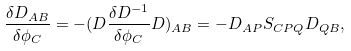Convert formula to latex. <formula><loc_0><loc_0><loc_500><loc_500>\frac { \delta D _ { A B } } { \delta \phi _ { C } } = - ( D \frac { \delta D ^ { - 1 } } { \delta \phi _ { C } } D ) _ { A B } = - D _ { A P } S _ { C P Q } D _ { Q B } ,</formula> 